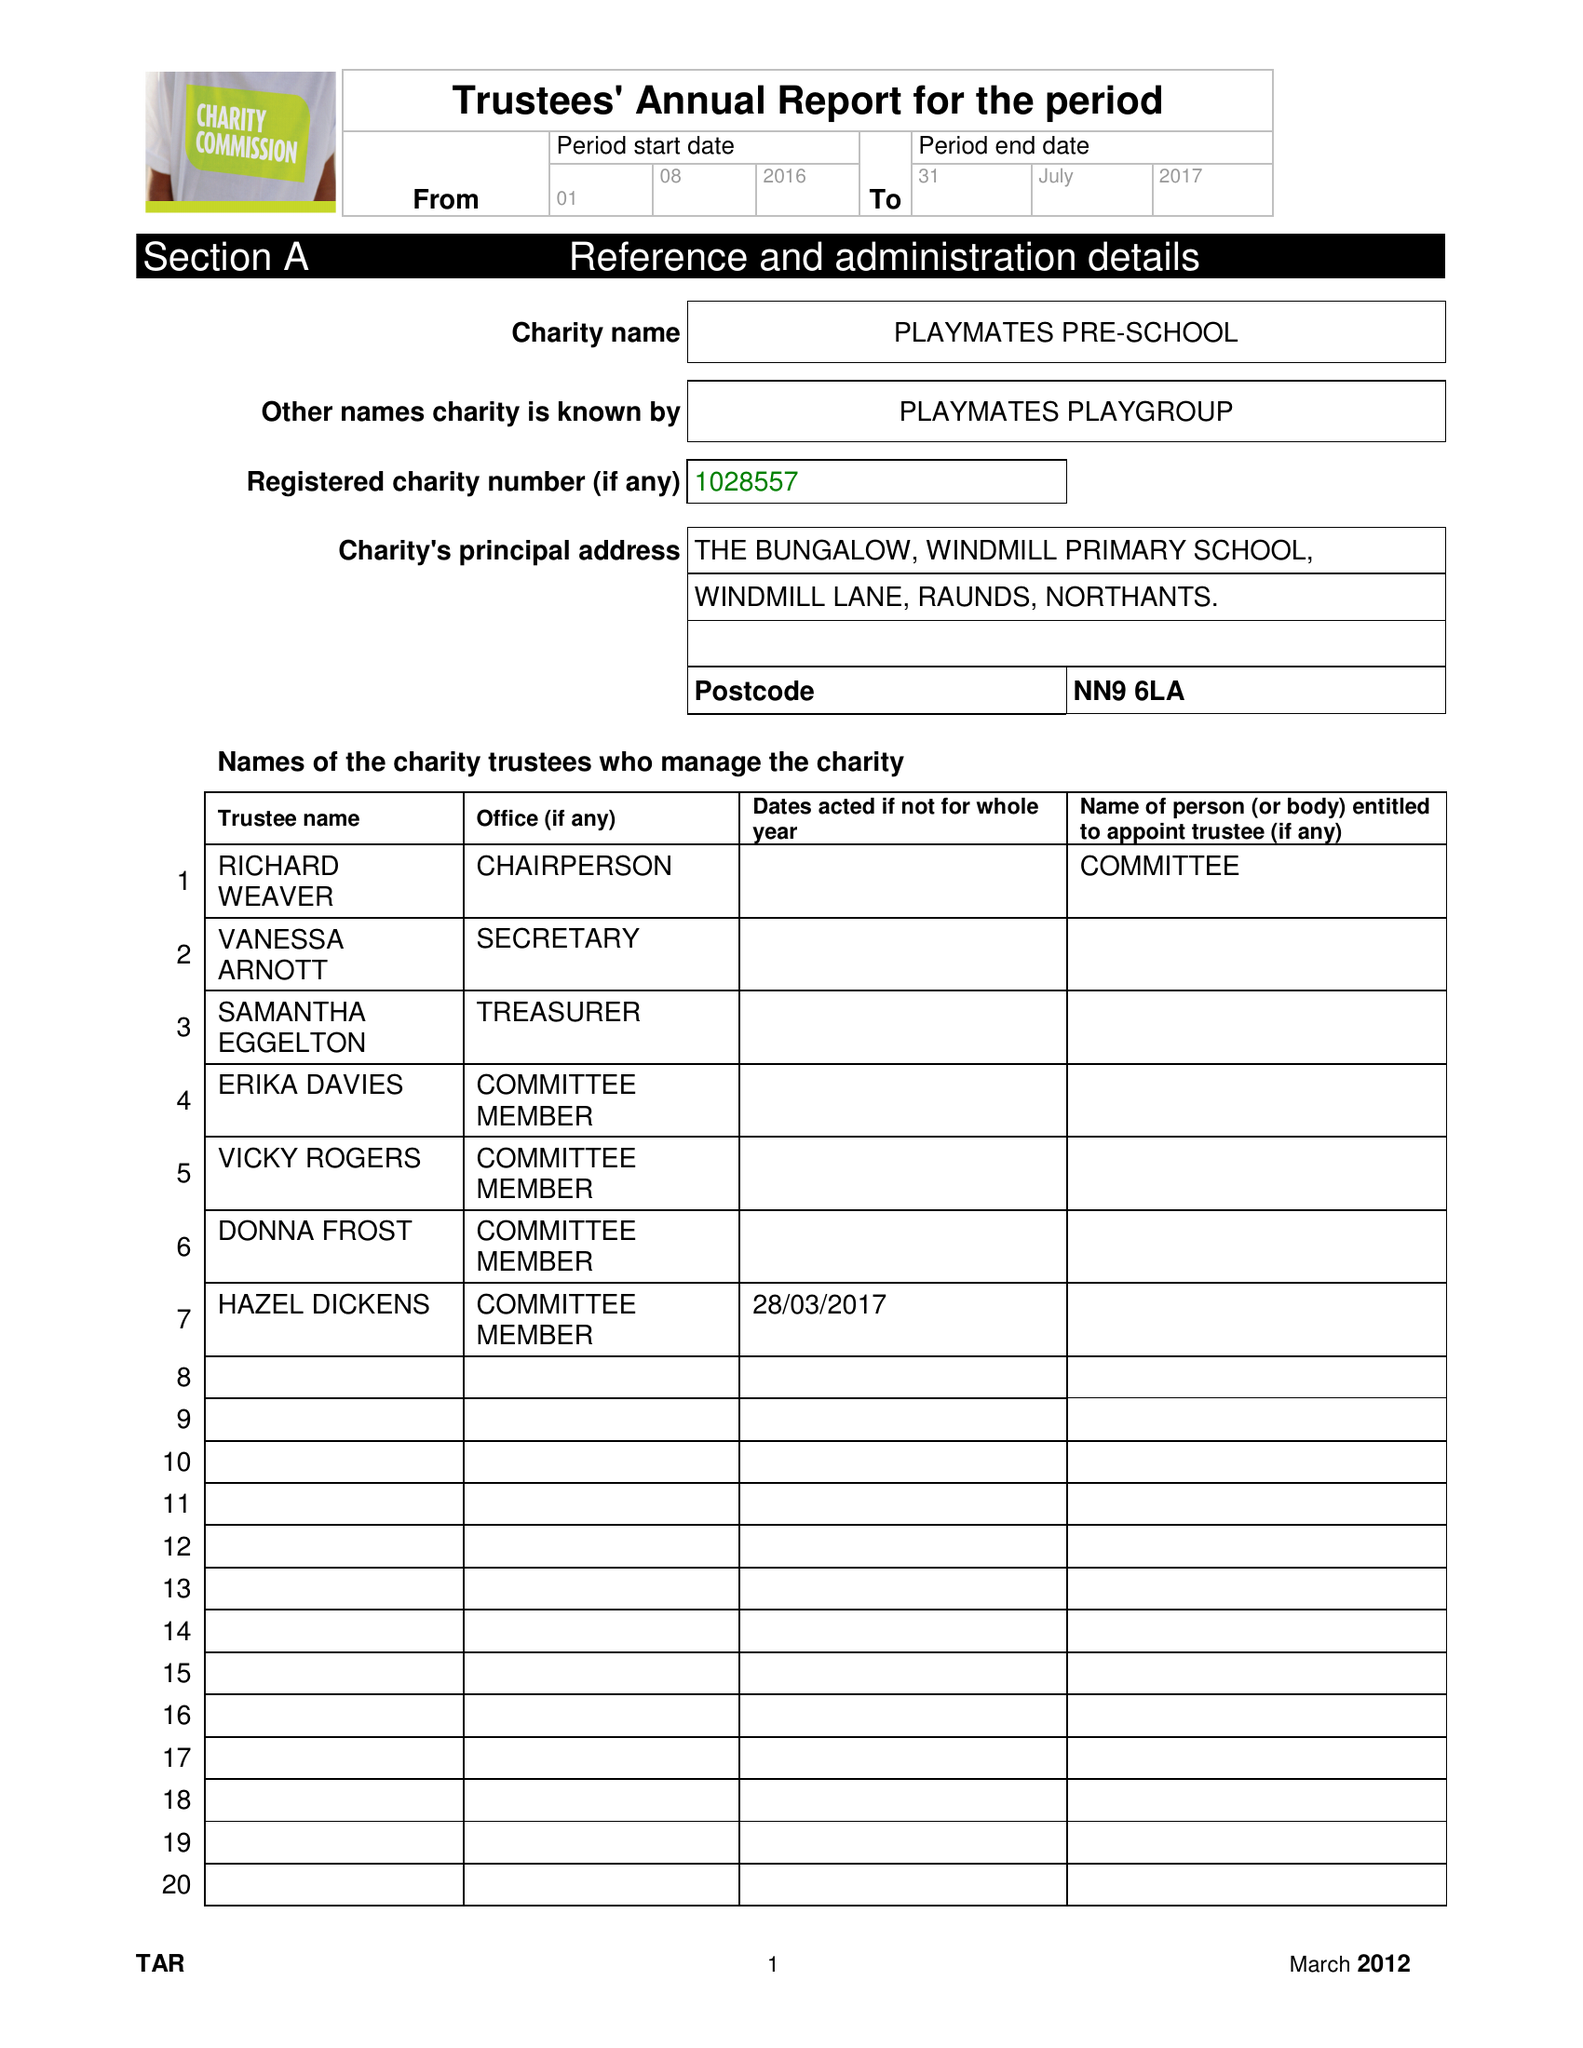What is the value for the address__street_line?
Answer the question using a single word or phrase. WINDMILL LANE 